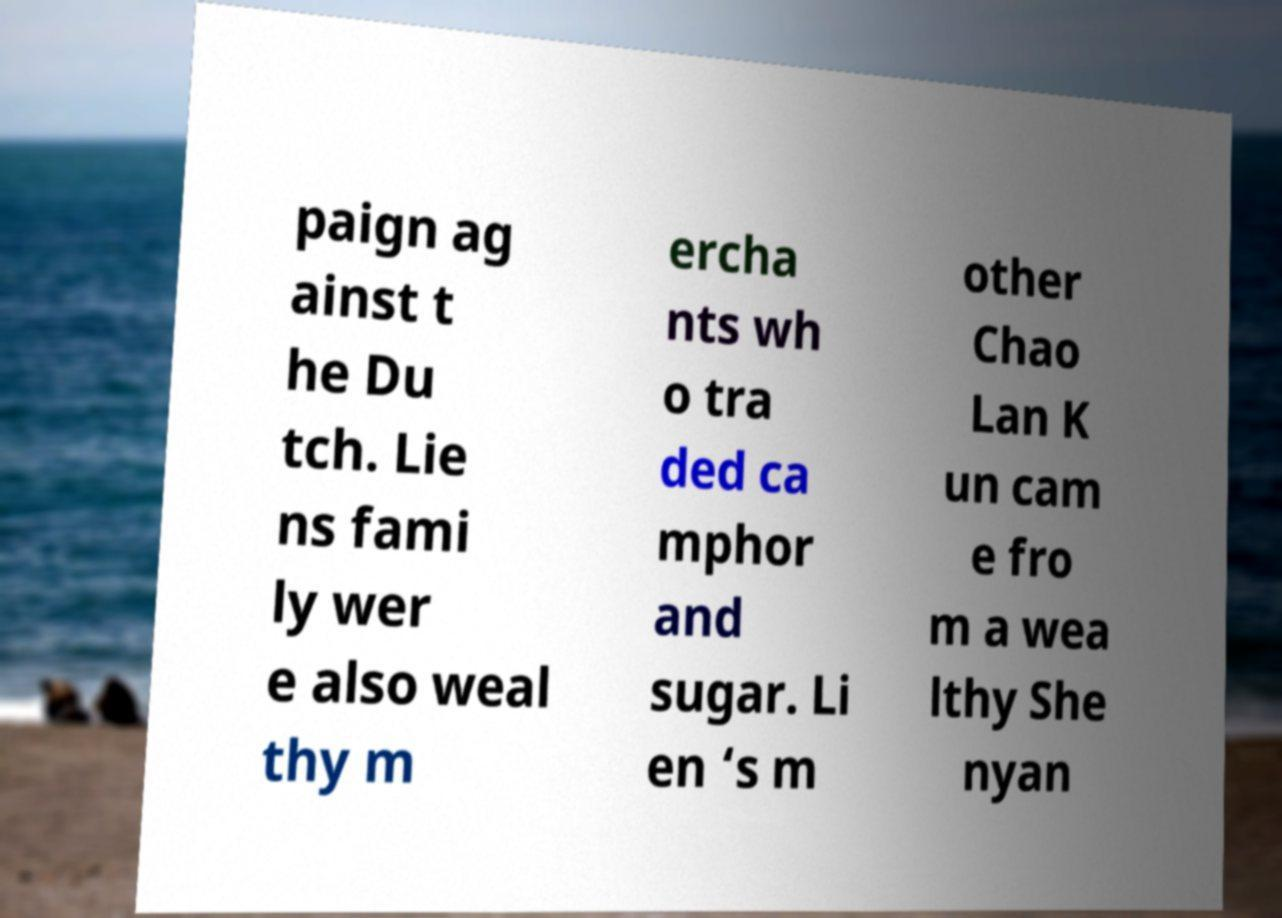Can you read and provide the text displayed in the image?This photo seems to have some interesting text. Can you extract and type it out for me? paign ag ainst t he Du tch. Lie ns fami ly wer e also weal thy m ercha nts wh o tra ded ca mphor and sugar. Li en ‘s m other Chao Lan K un cam e fro m a wea lthy She nyan 